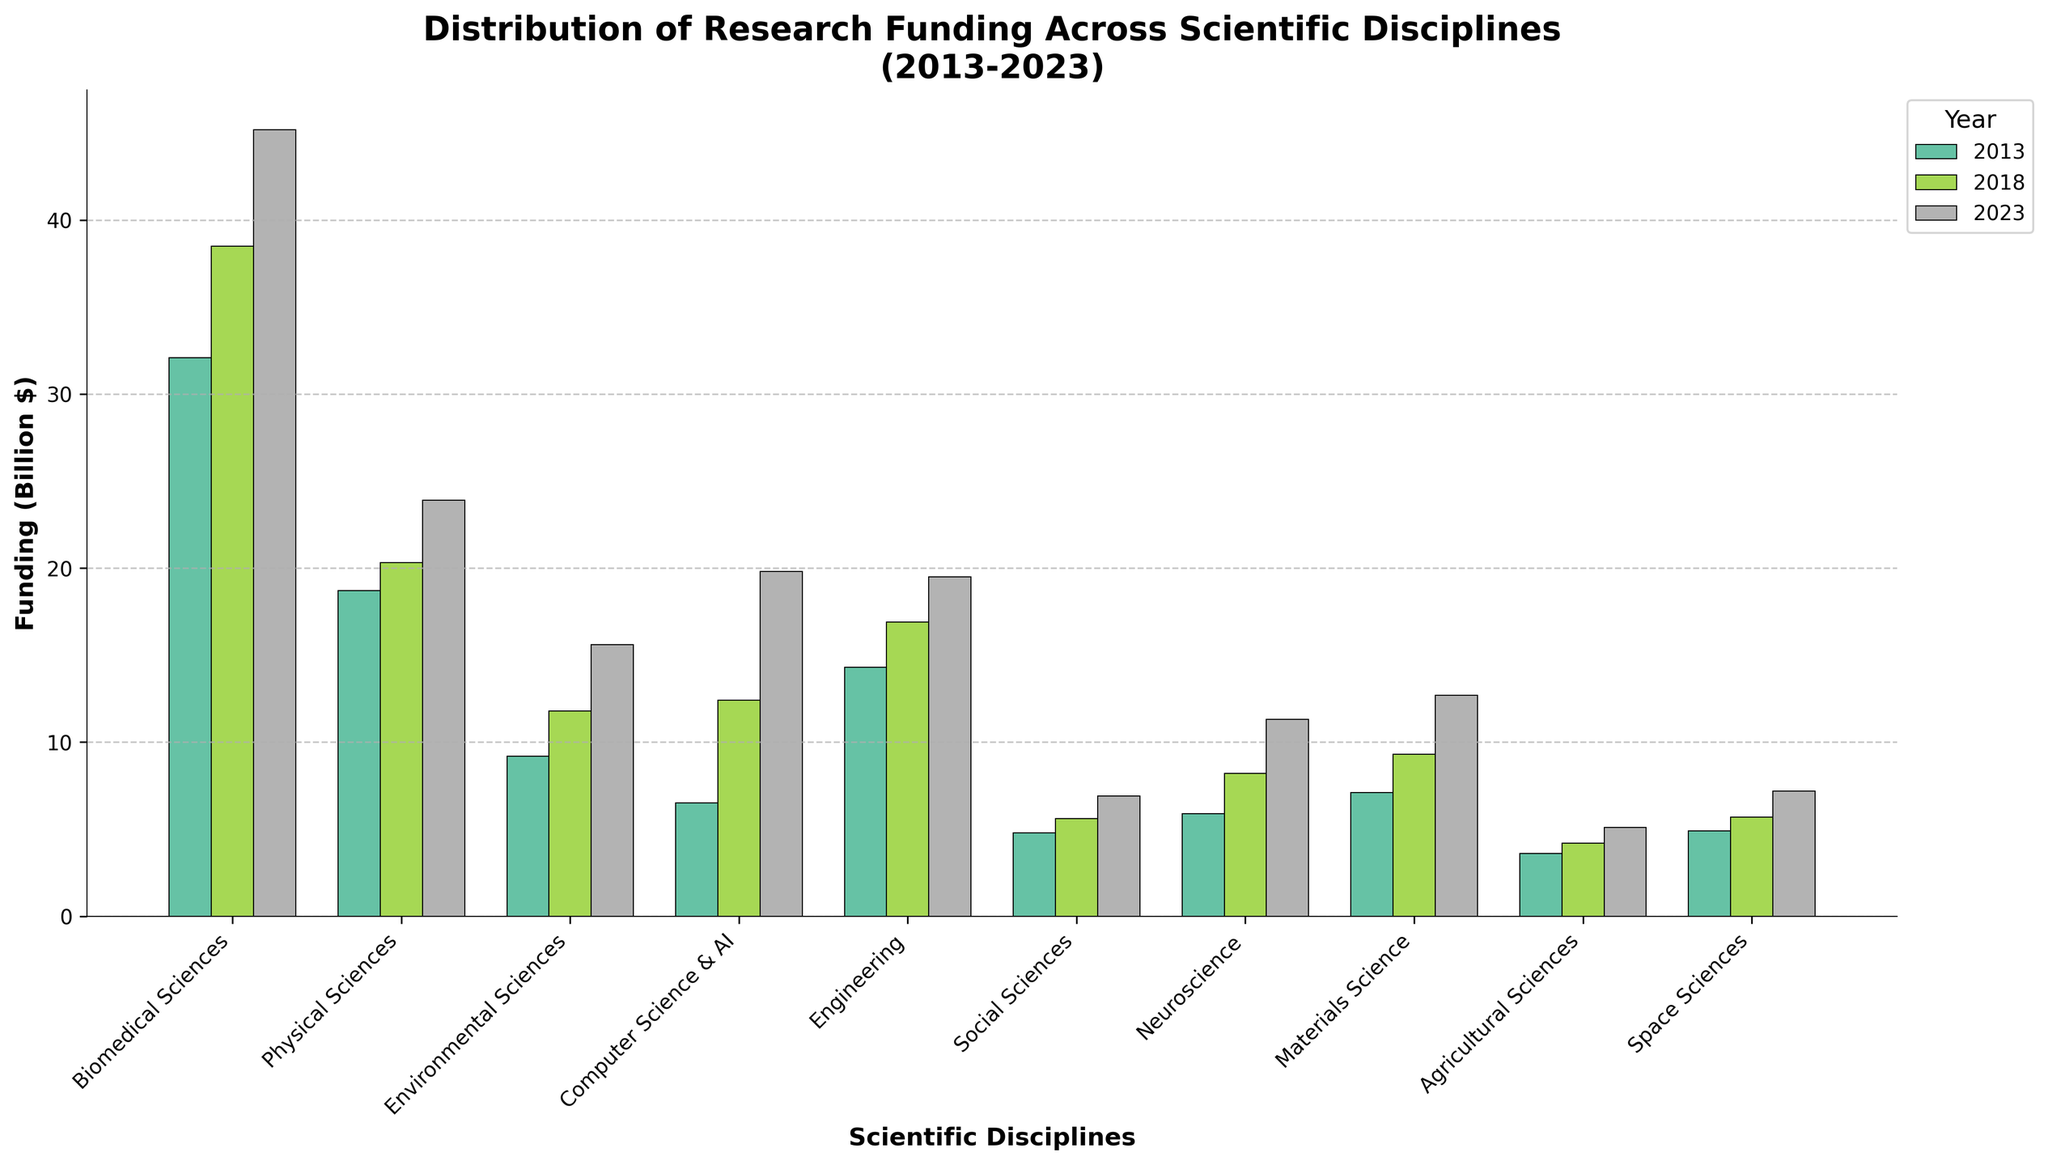What scientific discipline received the highest funding in 2023? Look at the funding bars for 2023, the tallest bar corresponds to Biomedical Sciences.
Answer: Biomedical Sciences Which scientific discipline saw the largest increase in funding from 2013 to 2023? Calculate the funding increase for each discipline from 2013 to 2023. Biomedical Sciences increased from 32.1 to 45.2, Physical Sciences from 18.7 to 23.9, etc., and Computer Science & AI from 6.5 to 19.8 saw the largest absolute increase.
Answer: Computer Science & AI How much more funding did Environmental Sciences receive in 2023 compared to 2013? Subtract the 2013 funding from the 2023 funding for Environmental Sciences: 15.6 - 9.2 = 6.4.
Answer: $6.4B Which year did Neuroscience see the highest funding, and what was the amount? Find the highest bar for Neuroscience under each year (2013, 2018, 2023). The highest is in 2023 with 11.3.
Answer: 2023, $11.3B By how much did funding for Materials Science increase from 2018 to 2023? Subtract the 2018 value from the 2023 value for Materials Science: 12.7 - 9.3 = 3.4.
Answer: $3.4B Rank the funding for Social Sciences across the years from highest to lowest. Compare the heights of the bars for Social Sciences across 2013, 2018, and 2023. Values are 6.9 (2023), 5.6 (2018), 4.8 (2013).
Answer: 2023, 2018, 2013 Which two scientific disciplines received equal funding in 2018? Observe the funding bars for 2018 and find bars with equal heights. None of the disciplines have exactly equal funding in 2018.
Answer: None How did funding for Physical Sciences change from 2013 to 2023, and what is the percentage increase? Funding for Physical Sciences in 2013 was 18.7 and in 2023 was 23.9; percentage increase is ((23.9 - 18.7) / 18.7) * 100 = 27.8%.
Answer: Increased by 27.8% What is the difference in 2023 funding between Computer Science & AI and Engineering? Subtract the 2023 funding for Engineering from Computer Science & AI: 19.8 - 19.5 = 0.3.
Answer: $0.3B Which scientific discipline had the smallest absolute increase in funding from 2013 to 2023? Calculate the difference for each discipline. Agricultural Sciences increased from 3.6 to 5.1, the smallest increase of $1.5B.
Answer: Agricultural Sciences 